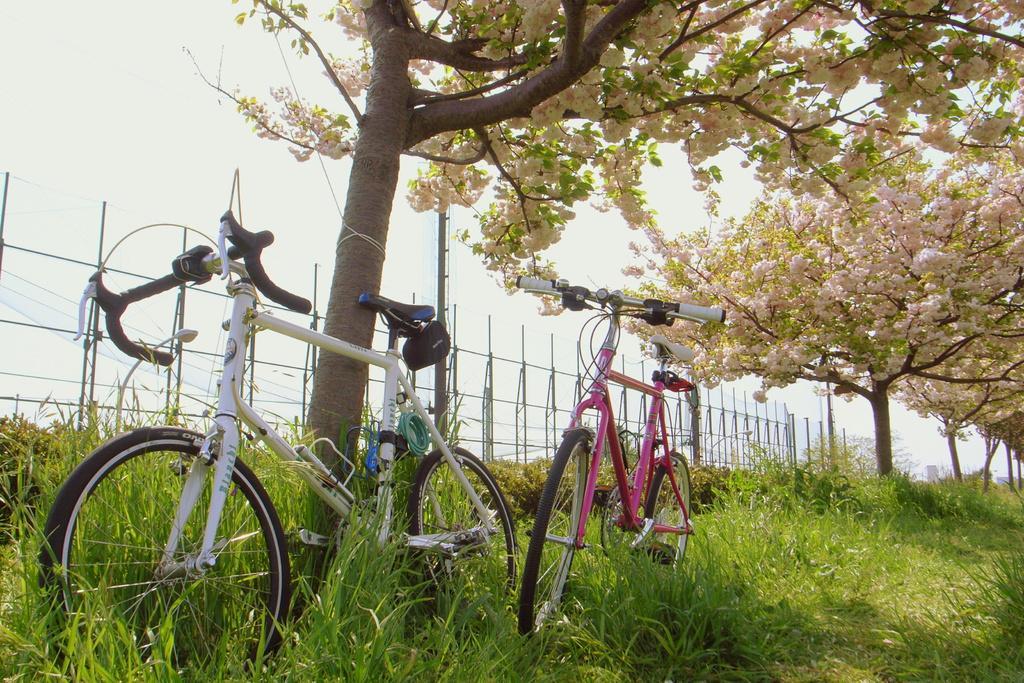Can you describe this image briefly? In this picture there are bicycles at the tree. At the back there is a fence and there are trees. At the top there is sky. At the bottom there is grass. There is a pole behind the fence. 